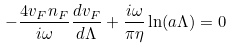Convert formula to latex. <formula><loc_0><loc_0><loc_500><loc_500>- \frac { 4 v _ { F } n _ { F } } { i \omega } \frac { d v _ { F } } { d \Lambda } + \frac { i \omega } { \pi \eta } \ln ( a \Lambda ) = 0</formula> 